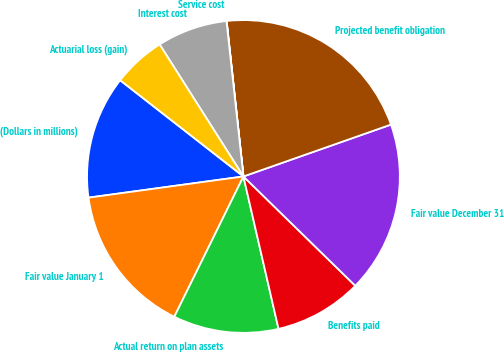Convert chart to OTSL. <chart><loc_0><loc_0><loc_500><loc_500><pie_chart><fcel>(Dollars in millions)<fcel>Fair value January 1<fcel>Actual return on plan assets<fcel>Benefits paid<fcel>Fair value December 31<fcel>Projected benefit obligation<fcel>Service cost<fcel>Interest cost<fcel>Actuarial loss (gain)<nl><fcel>12.71%<fcel>15.55%<fcel>10.89%<fcel>9.08%<fcel>17.7%<fcel>21.33%<fcel>0.02%<fcel>7.27%<fcel>5.45%<nl></chart> 